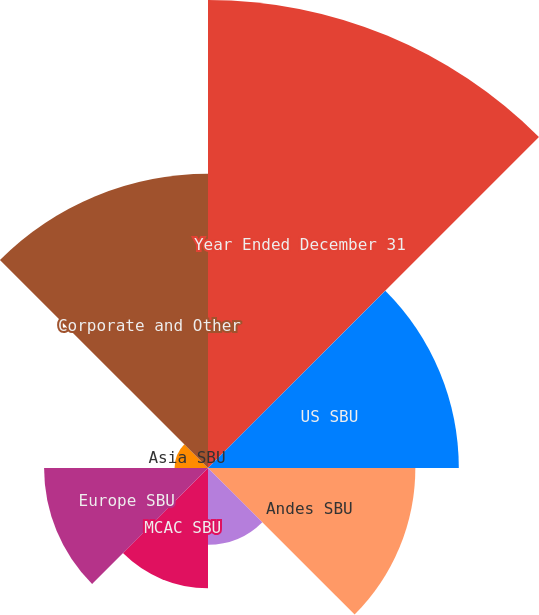<chart> <loc_0><loc_0><loc_500><loc_500><pie_chart><fcel>Year Ended December 31<fcel>US SBU<fcel>Andes SBU<fcel>Brazil SBU<fcel>MCAC SBU<fcel>Europe SBU<fcel>Asia SBU<fcel>Corporate and Other<nl><fcel>28.98%<fcel>15.53%<fcel>12.84%<fcel>4.76%<fcel>7.45%<fcel>10.15%<fcel>2.07%<fcel>18.22%<nl></chart> 